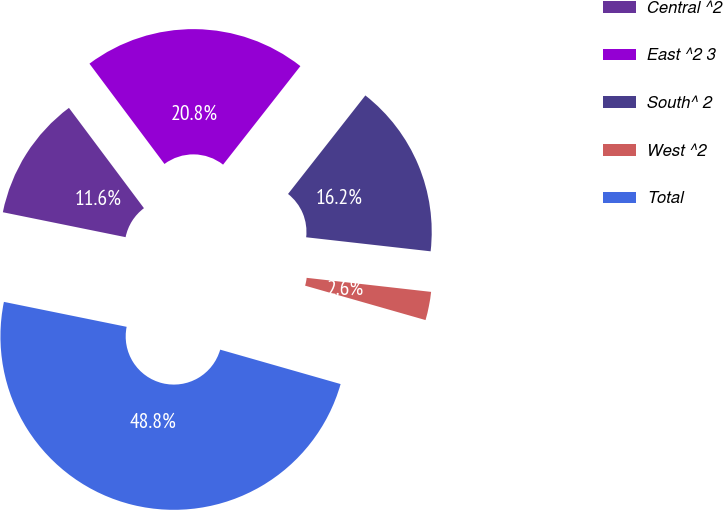Convert chart. <chart><loc_0><loc_0><loc_500><loc_500><pie_chart><fcel>Central ^2<fcel>East ^2 3<fcel>South^ 2<fcel>West ^2<fcel>Total<nl><fcel>11.59%<fcel>20.81%<fcel>16.2%<fcel>2.64%<fcel>48.76%<nl></chart> 